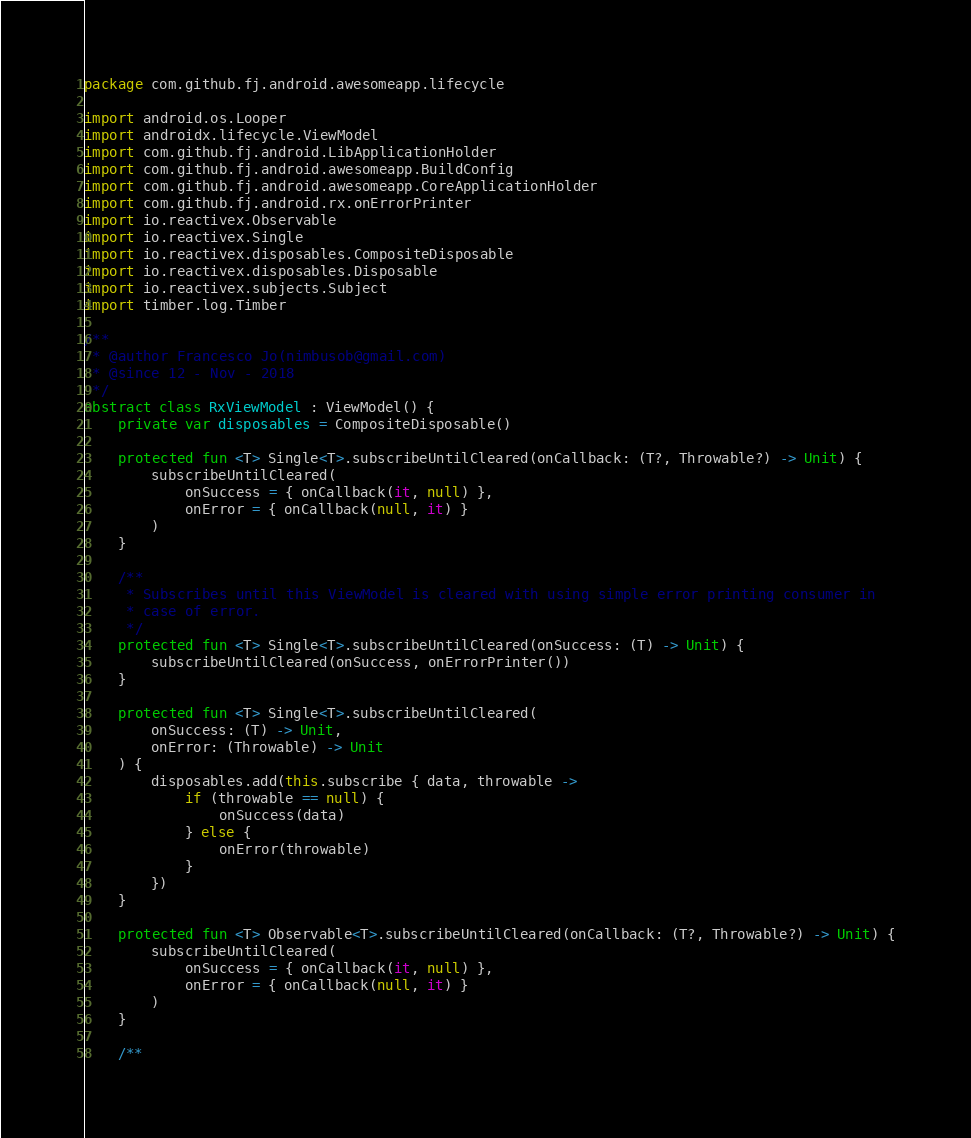<code> <loc_0><loc_0><loc_500><loc_500><_Kotlin_>package com.github.fj.android.awesomeapp.lifecycle

import android.os.Looper
import androidx.lifecycle.ViewModel
import com.github.fj.android.LibApplicationHolder
import com.github.fj.android.awesomeapp.BuildConfig
import com.github.fj.android.awesomeapp.CoreApplicationHolder
import com.github.fj.android.rx.onErrorPrinter
import io.reactivex.Observable
import io.reactivex.Single
import io.reactivex.disposables.CompositeDisposable
import io.reactivex.disposables.Disposable
import io.reactivex.subjects.Subject
import timber.log.Timber

/**
 * @author Francesco Jo(nimbusob@gmail.com)
 * @since 12 - Nov - 2018
 */
abstract class RxViewModel : ViewModel() {
    private var disposables = CompositeDisposable()

    protected fun <T> Single<T>.subscribeUntilCleared(onCallback: (T?, Throwable?) -> Unit) {
        subscribeUntilCleared(
            onSuccess = { onCallback(it, null) },
            onError = { onCallback(null, it) }
        )
    }

    /**
     * Subscribes until this ViewModel is cleared with using simple error printing consumer in
     * case of error.
     */
    protected fun <T> Single<T>.subscribeUntilCleared(onSuccess: (T) -> Unit) {
        subscribeUntilCleared(onSuccess, onErrorPrinter())
    }

    protected fun <T> Single<T>.subscribeUntilCleared(
        onSuccess: (T) -> Unit,
        onError: (Throwable) -> Unit
    ) {
        disposables.add(this.subscribe { data, throwable ->
            if (throwable == null) {
                onSuccess(data)
            } else {
                onError(throwable)
            }
        })
    }

    protected fun <T> Observable<T>.subscribeUntilCleared(onCallback: (T?, Throwable?) -> Unit) {
        subscribeUntilCleared(
            onSuccess = { onCallback(it, null) },
            onError = { onCallback(null, it) }
        )
    }

    /**</code> 